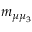Convert formula to latex. <formula><loc_0><loc_0><loc_500><loc_500>m _ { \mu \mu _ { 3 } }</formula> 